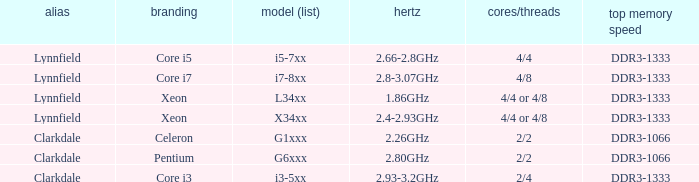What brand is model I7-8xx? Core i7. 